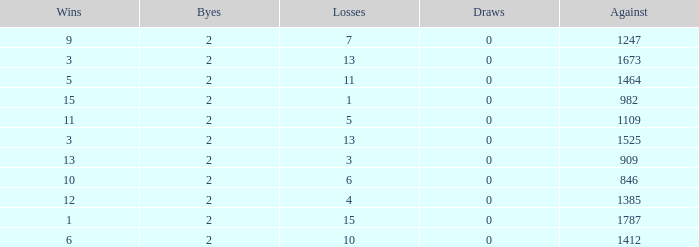What is the number listed under against when there were less than 13 losses and less than 2 byes? 0.0. 